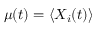<formula> <loc_0><loc_0><loc_500><loc_500>\mu ( t ) = \left < X _ { i } ( t ) \right ></formula> 